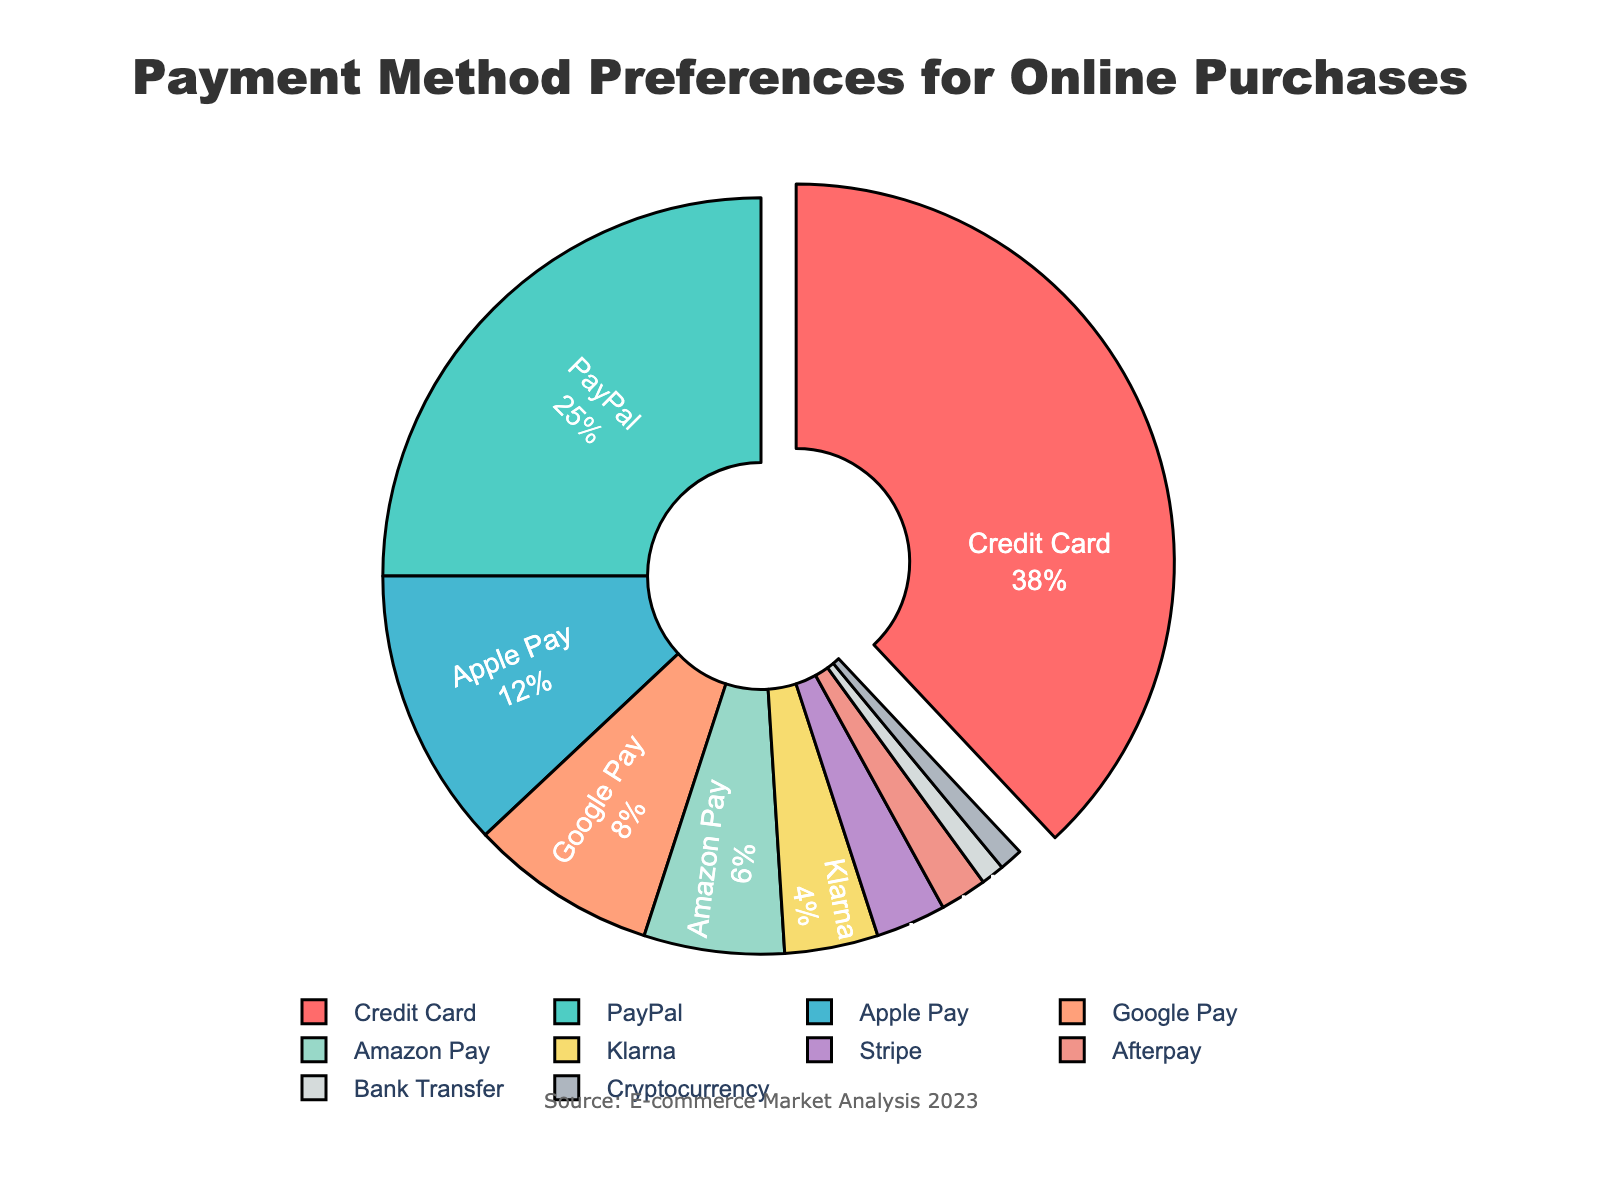Which payment method is preferred the most? The payment method that has the highest percentage is highlighted by being pulled out from the pie chart. In this case, it mentions 'Credit Card'.
Answer: Credit Card What is the percentage of people preferring Google Pay and Amazon Pay combined? Add the percentages of Google Pay (8%) and Amazon Pay (6%). So, 8 + 6 = 14%.
Answer: 14% Which payment method is the least popular? The payment methods with the smallest percentage of 1% are Bank Transfer and Cryptocurrency.
Answer: Bank Transfer and Cryptocurrency How much more popular is Apple Pay compared to Stripe? Subtract the percentage of Stripe (3%) from the percentage of Apple Pay (12%). So, 12 - 3 = 9%.
Answer: 9% Among digital wallets, which one is the most preferred method? Within the categorized digital wallets (Apple Pay, Google Pay, Amazon Pay, etc.), identify the one with the highest percentage. Apple Pay has 12%, which is the highest among the digital wallets.
Answer: Apple Pay What percentage of the total do PayPal and Afterpay make up together? Add the percentages of PayPal (25%) and Afterpay (2%). So, 25 + 2 = 27%.
Answer: 27% What percentage is attributed to payment methods other than Credit Card? Subtract the percentage of Credit Card (38%) from 100%. Therefore, 100 - 38 = 62%.
Answer: 62% Which method has a color representing '#FF6B6B' on the chart? The color '#FF6B6B' corresponds to the section of the pie chart representing Credit Card.
Answer: Credit Card Is Google Pay as popular as Amazon Pay and Klarna combined? Add the percentages of Amazon Pay (6%) and Klarna (4%). So, 6 + 4 = 10%. Compare this sum to Google Pay’s percentage, which is 8%. 8% is less than 10%.
Answer: No How many payment methods listed have a preference percentage of less than 5%? Count the payment methods with percentages: Klarna (4%), Stripe (3%), Afterpay (2%), Bank Transfer (1%), and Cryptocurrency (1%), which are less than 5%. That's 5 payment methods.
Answer: 5 